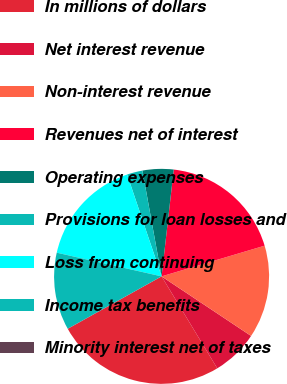<chart> <loc_0><loc_0><loc_500><loc_500><pie_chart><fcel>In millions of dollars<fcel>Net interest revenue<fcel>Non-interest revenue<fcel>Revenues net of interest<fcel>Operating expenses<fcel>Provisions for loan losses and<fcel>Loss from continuing<fcel>Income tax benefits<fcel>Minority interest net of taxes<nl><fcel>25.55%<fcel>6.99%<fcel>13.95%<fcel>18.59%<fcel>4.66%<fcel>2.34%<fcel>16.27%<fcel>11.63%<fcel>0.02%<nl></chart> 